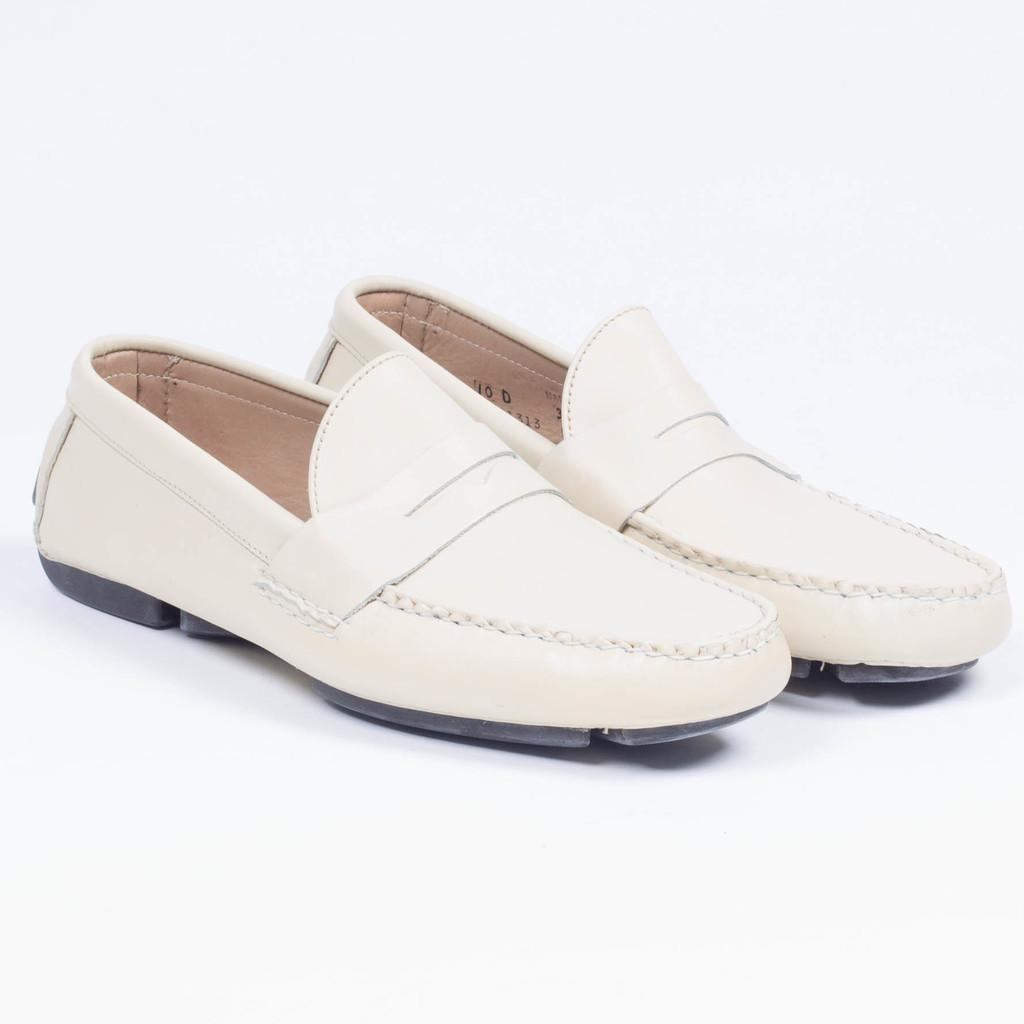What objects are present in the image? There are shoes in the image. What color is the background of the image? The background of the image is white. Where is the shelf with the bread located in the image? There is no shelf or bread present in the image; it only features shoes against a white background. 